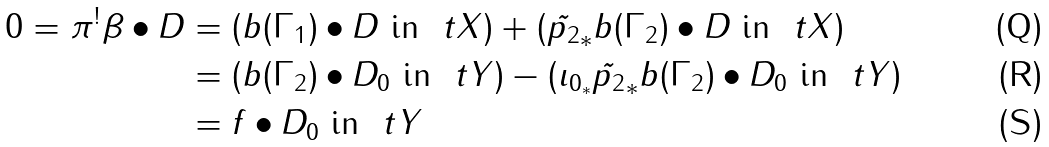Convert formula to latex. <formula><loc_0><loc_0><loc_500><loc_500>0 = \pi ^ { ! } \beta \bullet D & = \left ( b ( \Gamma _ { 1 } ) \bullet D \text { in } \ t X \right ) + \left ( \tilde { p _ { 2 } } _ { * } b ( \Gamma _ { 2 } ) \bullet D \text { in } \ t X \right ) \\ & = \left ( b ( \Gamma _ { 2 } ) \bullet D _ { 0 } \text { in } \ t Y \right ) - \left ( \imath _ { 0 _ { * } } \tilde { p _ { 2 } } _ { * } b ( \Gamma _ { 2 } ) \bullet D _ { 0 } \text { in } \ t Y \right ) \\ & = f \bullet D _ { 0 } \text { in } \ t Y</formula> 